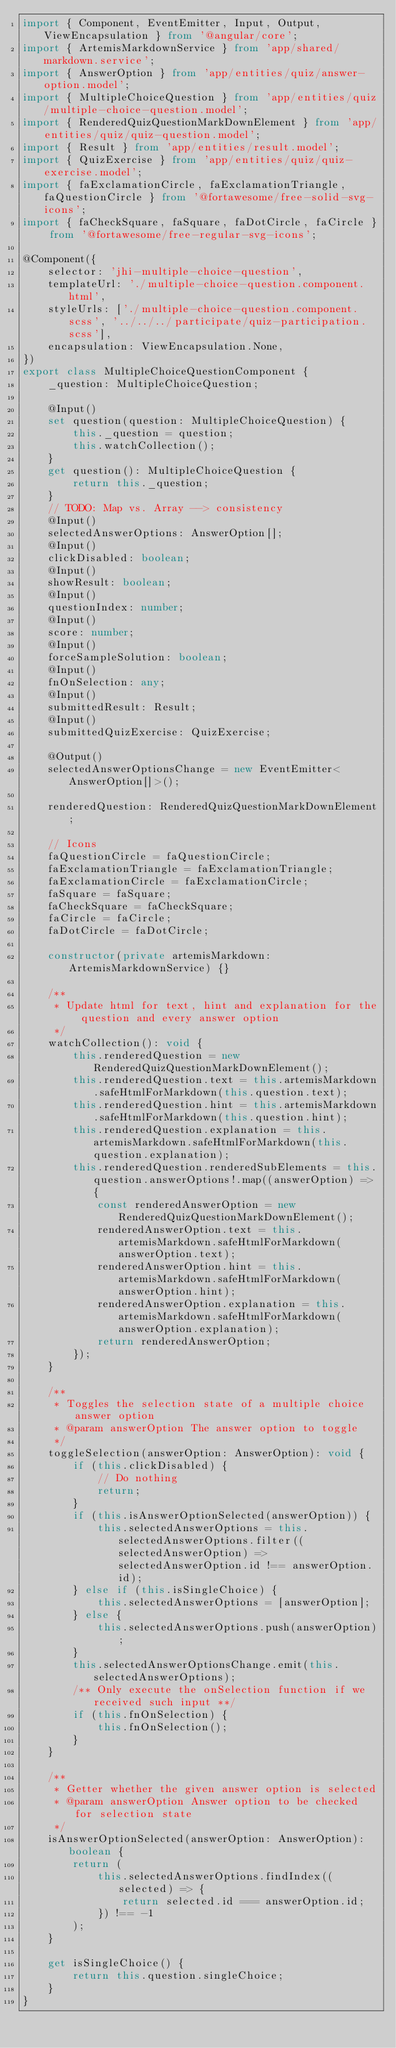Convert code to text. <code><loc_0><loc_0><loc_500><loc_500><_TypeScript_>import { Component, EventEmitter, Input, Output, ViewEncapsulation } from '@angular/core';
import { ArtemisMarkdownService } from 'app/shared/markdown.service';
import { AnswerOption } from 'app/entities/quiz/answer-option.model';
import { MultipleChoiceQuestion } from 'app/entities/quiz/multiple-choice-question.model';
import { RenderedQuizQuestionMarkDownElement } from 'app/entities/quiz/quiz-question.model';
import { Result } from 'app/entities/result.model';
import { QuizExercise } from 'app/entities/quiz/quiz-exercise.model';
import { faExclamationCircle, faExclamationTriangle, faQuestionCircle } from '@fortawesome/free-solid-svg-icons';
import { faCheckSquare, faSquare, faDotCircle, faCircle } from '@fortawesome/free-regular-svg-icons';

@Component({
    selector: 'jhi-multiple-choice-question',
    templateUrl: './multiple-choice-question.component.html',
    styleUrls: ['./multiple-choice-question.component.scss', '../../../participate/quiz-participation.scss'],
    encapsulation: ViewEncapsulation.None,
})
export class MultipleChoiceQuestionComponent {
    _question: MultipleChoiceQuestion;

    @Input()
    set question(question: MultipleChoiceQuestion) {
        this._question = question;
        this.watchCollection();
    }
    get question(): MultipleChoiceQuestion {
        return this._question;
    }
    // TODO: Map vs. Array --> consistency
    @Input()
    selectedAnswerOptions: AnswerOption[];
    @Input()
    clickDisabled: boolean;
    @Input()
    showResult: boolean;
    @Input()
    questionIndex: number;
    @Input()
    score: number;
    @Input()
    forceSampleSolution: boolean;
    @Input()
    fnOnSelection: any;
    @Input()
    submittedResult: Result;
    @Input()
    submittedQuizExercise: QuizExercise;

    @Output()
    selectedAnswerOptionsChange = new EventEmitter<AnswerOption[]>();

    renderedQuestion: RenderedQuizQuestionMarkDownElement;

    // Icons
    faQuestionCircle = faQuestionCircle;
    faExclamationTriangle = faExclamationTriangle;
    faExclamationCircle = faExclamationCircle;
    faSquare = faSquare;
    faCheckSquare = faCheckSquare;
    faCircle = faCircle;
    faDotCircle = faDotCircle;

    constructor(private artemisMarkdown: ArtemisMarkdownService) {}

    /**
     * Update html for text, hint and explanation for the question and every answer option
     */
    watchCollection(): void {
        this.renderedQuestion = new RenderedQuizQuestionMarkDownElement();
        this.renderedQuestion.text = this.artemisMarkdown.safeHtmlForMarkdown(this.question.text);
        this.renderedQuestion.hint = this.artemisMarkdown.safeHtmlForMarkdown(this.question.hint);
        this.renderedQuestion.explanation = this.artemisMarkdown.safeHtmlForMarkdown(this.question.explanation);
        this.renderedQuestion.renderedSubElements = this.question.answerOptions!.map((answerOption) => {
            const renderedAnswerOption = new RenderedQuizQuestionMarkDownElement();
            renderedAnswerOption.text = this.artemisMarkdown.safeHtmlForMarkdown(answerOption.text);
            renderedAnswerOption.hint = this.artemisMarkdown.safeHtmlForMarkdown(answerOption.hint);
            renderedAnswerOption.explanation = this.artemisMarkdown.safeHtmlForMarkdown(answerOption.explanation);
            return renderedAnswerOption;
        });
    }

    /**
     * Toggles the selection state of a multiple choice answer option
     * @param answerOption The answer option to toggle
     */
    toggleSelection(answerOption: AnswerOption): void {
        if (this.clickDisabled) {
            // Do nothing
            return;
        }
        if (this.isAnswerOptionSelected(answerOption)) {
            this.selectedAnswerOptions = this.selectedAnswerOptions.filter((selectedAnswerOption) => selectedAnswerOption.id !== answerOption.id);
        } else if (this.isSingleChoice) {
            this.selectedAnswerOptions = [answerOption];
        } else {
            this.selectedAnswerOptions.push(answerOption);
        }
        this.selectedAnswerOptionsChange.emit(this.selectedAnswerOptions);
        /** Only execute the onSelection function if we received such input **/
        if (this.fnOnSelection) {
            this.fnOnSelection();
        }
    }

    /**
     * Getter whether the given answer option is selected
     * @param answerOption Answer option to be checked for selection state
     */
    isAnswerOptionSelected(answerOption: AnswerOption): boolean {
        return (
            this.selectedAnswerOptions.findIndex((selected) => {
                return selected.id === answerOption.id;
            }) !== -1
        );
    }

    get isSingleChoice() {
        return this.question.singleChoice;
    }
}
</code> 